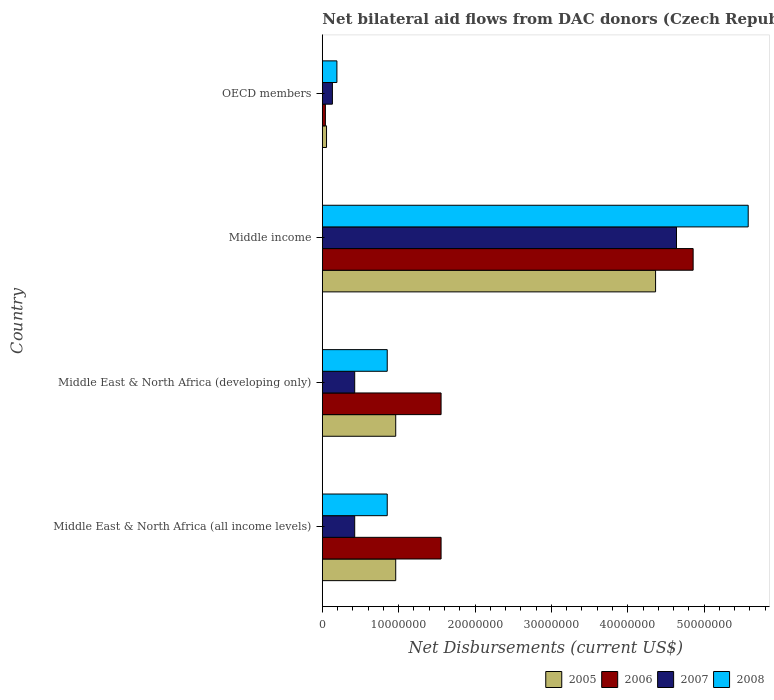How many different coloured bars are there?
Provide a succinct answer. 4. How many groups of bars are there?
Your answer should be compact. 4. How many bars are there on the 2nd tick from the top?
Your response must be concise. 4. What is the label of the 3rd group of bars from the top?
Give a very brief answer. Middle East & North Africa (developing only). In how many cases, is the number of bars for a given country not equal to the number of legend labels?
Your answer should be compact. 0. What is the net bilateral aid flows in 2008 in Middle income?
Ensure brevity in your answer.  5.58e+07. Across all countries, what is the maximum net bilateral aid flows in 2007?
Keep it short and to the point. 4.64e+07. Across all countries, what is the minimum net bilateral aid flows in 2005?
Ensure brevity in your answer.  5.50e+05. What is the total net bilateral aid flows in 2005 in the graph?
Make the answer very short. 6.34e+07. What is the difference between the net bilateral aid flows in 2008 in Middle East & North Africa (developing only) and that in OECD members?
Offer a very short reply. 6.59e+06. What is the difference between the net bilateral aid flows in 2005 in OECD members and the net bilateral aid flows in 2006 in Middle East & North Africa (all income levels)?
Your answer should be compact. -1.50e+07. What is the average net bilateral aid flows in 2006 per country?
Your answer should be very brief. 2.00e+07. What is the difference between the net bilateral aid flows in 2006 and net bilateral aid flows in 2005 in Middle East & North Africa (developing only)?
Provide a short and direct response. 5.94e+06. What is the ratio of the net bilateral aid flows in 2005 in Middle East & North Africa (all income levels) to that in OECD members?
Make the answer very short. 17.47. What is the difference between the highest and the second highest net bilateral aid flows in 2007?
Your response must be concise. 4.21e+07. What is the difference between the highest and the lowest net bilateral aid flows in 2008?
Your answer should be compact. 5.39e+07. In how many countries, is the net bilateral aid flows in 2005 greater than the average net bilateral aid flows in 2005 taken over all countries?
Provide a succinct answer. 1. Is the sum of the net bilateral aid flows in 2007 in Middle East & North Africa (all income levels) and Middle East & North Africa (developing only) greater than the maximum net bilateral aid flows in 2005 across all countries?
Keep it short and to the point. No. Is it the case that in every country, the sum of the net bilateral aid flows in 2008 and net bilateral aid flows in 2007 is greater than the sum of net bilateral aid flows in 2006 and net bilateral aid flows in 2005?
Give a very brief answer. No. How many bars are there?
Your response must be concise. 16. Are all the bars in the graph horizontal?
Offer a very short reply. Yes. How many countries are there in the graph?
Provide a succinct answer. 4. Are the values on the major ticks of X-axis written in scientific E-notation?
Make the answer very short. No. Does the graph contain any zero values?
Provide a succinct answer. No. Where does the legend appear in the graph?
Offer a very short reply. Bottom right. What is the title of the graph?
Provide a short and direct response. Net bilateral aid flows from DAC donors (Czech Republic). Does "1996" appear as one of the legend labels in the graph?
Ensure brevity in your answer.  No. What is the label or title of the X-axis?
Your answer should be compact. Net Disbursements (current US$). What is the label or title of the Y-axis?
Make the answer very short. Country. What is the Net Disbursements (current US$) in 2005 in Middle East & North Africa (all income levels)?
Your answer should be very brief. 9.61e+06. What is the Net Disbursements (current US$) of 2006 in Middle East & North Africa (all income levels)?
Keep it short and to the point. 1.56e+07. What is the Net Disbursements (current US$) of 2007 in Middle East & North Africa (all income levels)?
Ensure brevity in your answer.  4.24e+06. What is the Net Disbursements (current US$) in 2008 in Middle East & North Africa (all income levels)?
Your answer should be very brief. 8.50e+06. What is the Net Disbursements (current US$) of 2005 in Middle East & North Africa (developing only)?
Provide a succinct answer. 9.61e+06. What is the Net Disbursements (current US$) in 2006 in Middle East & North Africa (developing only)?
Your response must be concise. 1.56e+07. What is the Net Disbursements (current US$) in 2007 in Middle East & North Africa (developing only)?
Ensure brevity in your answer.  4.24e+06. What is the Net Disbursements (current US$) of 2008 in Middle East & North Africa (developing only)?
Your response must be concise. 8.50e+06. What is the Net Disbursements (current US$) of 2005 in Middle income?
Give a very brief answer. 4.36e+07. What is the Net Disbursements (current US$) in 2006 in Middle income?
Your answer should be compact. 4.86e+07. What is the Net Disbursements (current US$) in 2007 in Middle income?
Give a very brief answer. 4.64e+07. What is the Net Disbursements (current US$) of 2008 in Middle income?
Your response must be concise. 5.58e+07. What is the Net Disbursements (current US$) of 2007 in OECD members?
Provide a succinct answer. 1.32e+06. What is the Net Disbursements (current US$) in 2008 in OECD members?
Ensure brevity in your answer.  1.91e+06. Across all countries, what is the maximum Net Disbursements (current US$) in 2005?
Offer a terse response. 4.36e+07. Across all countries, what is the maximum Net Disbursements (current US$) of 2006?
Your answer should be compact. 4.86e+07. Across all countries, what is the maximum Net Disbursements (current US$) of 2007?
Offer a very short reply. 4.64e+07. Across all countries, what is the maximum Net Disbursements (current US$) in 2008?
Give a very brief answer. 5.58e+07. Across all countries, what is the minimum Net Disbursements (current US$) of 2005?
Offer a very short reply. 5.50e+05. Across all countries, what is the minimum Net Disbursements (current US$) in 2006?
Ensure brevity in your answer.  4.00e+05. Across all countries, what is the minimum Net Disbursements (current US$) in 2007?
Your answer should be very brief. 1.32e+06. Across all countries, what is the minimum Net Disbursements (current US$) in 2008?
Provide a succinct answer. 1.91e+06. What is the total Net Disbursements (current US$) in 2005 in the graph?
Provide a short and direct response. 6.34e+07. What is the total Net Disbursements (current US$) of 2006 in the graph?
Your answer should be compact. 8.01e+07. What is the total Net Disbursements (current US$) of 2007 in the graph?
Your answer should be very brief. 5.62e+07. What is the total Net Disbursements (current US$) in 2008 in the graph?
Ensure brevity in your answer.  7.47e+07. What is the difference between the Net Disbursements (current US$) of 2005 in Middle East & North Africa (all income levels) and that in Middle East & North Africa (developing only)?
Offer a very short reply. 0. What is the difference between the Net Disbursements (current US$) in 2006 in Middle East & North Africa (all income levels) and that in Middle East & North Africa (developing only)?
Offer a very short reply. 0. What is the difference between the Net Disbursements (current US$) in 2007 in Middle East & North Africa (all income levels) and that in Middle East & North Africa (developing only)?
Offer a terse response. 0. What is the difference between the Net Disbursements (current US$) of 2005 in Middle East & North Africa (all income levels) and that in Middle income?
Provide a short and direct response. -3.40e+07. What is the difference between the Net Disbursements (current US$) in 2006 in Middle East & North Africa (all income levels) and that in Middle income?
Ensure brevity in your answer.  -3.30e+07. What is the difference between the Net Disbursements (current US$) of 2007 in Middle East & North Africa (all income levels) and that in Middle income?
Offer a terse response. -4.21e+07. What is the difference between the Net Disbursements (current US$) of 2008 in Middle East & North Africa (all income levels) and that in Middle income?
Offer a terse response. -4.73e+07. What is the difference between the Net Disbursements (current US$) in 2005 in Middle East & North Africa (all income levels) and that in OECD members?
Your response must be concise. 9.06e+06. What is the difference between the Net Disbursements (current US$) in 2006 in Middle East & North Africa (all income levels) and that in OECD members?
Offer a very short reply. 1.52e+07. What is the difference between the Net Disbursements (current US$) in 2007 in Middle East & North Africa (all income levels) and that in OECD members?
Offer a very short reply. 2.92e+06. What is the difference between the Net Disbursements (current US$) in 2008 in Middle East & North Africa (all income levels) and that in OECD members?
Provide a short and direct response. 6.59e+06. What is the difference between the Net Disbursements (current US$) of 2005 in Middle East & North Africa (developing only) and that in Middle income?
Offer a very short reply. -3.40e+07. What is the difference between the Net Disbursements (current US$) of 2006 in Middle East & North Africa (developing only) and that in Middle income?
Provide a succinct answer. -3.30e+07. What is the difference between the Net Disbursements (current US$) of 2007 in Middle East & North Africa (developing only) and that in Middle income?
Offer a terse response. -4.21e+07. What is the difference between the Net Disbursements (current US$) of 2008 in Middle East & North Africa (developing only) and that in Middle income?
Offer a terse response. -4.73e+07. What is the difference between the Net Disbursements (current US$) of 2005 in Middle East & North Africa (developing only) and that in OECD members?
Ensure brevity in your answer.  9.06e+06. What is the difference between the Net Disbursements (current US$) of 2006 in Middle East & North Africa (developing only) and that in OECD members?
Give a very brief answer. 1.52e+07. What is the difference between the Net Disbursements (current US$) of 2007 in Middle East & North Africa (developing only) and that in OECD members?
Your answer should be very brief. 2.92e+06. What is the difference between the Net Disbursements (current US$) in 2008 in Middle East & North Africa (developing only) and that in OECD members?
Give a very brief answer. 6.59e+06. What is the difference between the Net Disbursements (current US$) of 2005 in Middle income and that in OECD members?
Provide a succinct answer. 4.31e+07. What is the difference between the Net Disbursements (current US$) of 2006 in Middle income and that in OECD members?
Your answer should be compact. 4.82e+07. What is the difference between the Net Disbursements (current US$) of 2007 in Middle income and that in OECD members?
Offer a very short reply. 4.51e+07. What is the difference between the Net Disbursements (current US$) in 2008 in Middle income and that in OECD members?
Your answer should be very brief. 5.39e+07. What is the difference between the Net Disbursements (current US$) in 2005 in Middle East & North Africa (all income levels) and the Net Disbursements (current US$) in 2006 in Middle East & North Africa (developing only)?
Provide a succinct answer. -5.94e+06. What is the difference between the Net Disbursements (current US$) of 2005 in Middle East & North Africa (all income levels) and the Net Disbursements (current US$) of 2007 in Middle East & North Africa (developing only)?
Give a very brief answer. 5.37e+06. What is the difference between the Net Disbursements (current US$) of 2005 in Middle East & North Africa (all income levels) and the Net Disbursements (current US$) of 2008 in Middle East & North Africa (developing only)?
Provide a short and direct response. 1.11e+06. What is the difference between the Net Disbursements (current US$) of 2006 in Middle East & North Africa (all income levels) and the Net Disbursements (current US$) of 2007 in Middle East & North Africa (developing only)?
Make the answer very short. 1.13e+07. What is the difference between the Net Disbursements (current US$) in 2006 in Middle East & North Africa (all income levels) and the Net Disbursements (current US$) in 2008 in Middle East & North Africa (developing only)?
Give a very brief answer. 7.05e+06. What is the difference between the Net Disbursements (current US$) in 2007 in Middle East & North Africa (all income levels) and the Net Disbursements (current US$) in 2008 in Middle East & North Africa (developing only)?
Make the answer very short. -4.26e+06. What is the difference between the Net Disbursements (current US$) of 2005 in Middle East & North Africa (all income levels) and the Net Disbursements (current US$) of 2006 in Middle income?
Keep it short and to the point. -3.90e+07. What is the difference between the Net Disbursements (current US$) of 2005 in Middle East & North Africa (all income levels) and the Net Disbursements (current US$) of 2007 in Middle income?
Provide a succinct answer. -3.68e+07. What is the difference between the Net Disbursements (current US$) of 2005 in Middle East & North Africa (all income levels) and the Net Disbursements (current US$) of 2008 in Middle income?
Provide a succinct answer. -4.62e+07. What is the difference between the Net Disbursements (current US$) in 2006 in Middle East & North Africa (all income levels) and the Net Disbursements (current US$) in 2007 in Middle income?
Ensure brevity in your answer.  -3.08e+07. What is the difference between the Net Disbursements (current US$) of 2006 in Middle East & North Africa (all income levels) and the Net Disbursements (current US$) of 2008 in Middle income?
Give a very brief answer. -4.02e+07. What is the difference between the Net Disbursements (current US$) in 2007 in Middle East & North Africa (all income levels) and the Net Disbursements (current US$) in 2008 in Middle income?
Ensure brevity in your answer.  -5.15e+07. What is the difference between the Net Disbursements (current US$) of 2005 in Middle East & North Africa (all income levels) and the Net Disbursements (current US$) of 2006 in OECD members?
Ensure brevity in your answer.  9.21e+06. What is the difference between the Net Disbursements (current US$) of 2005 in Middle East & North Africa (all income levels) and the Net Disbursements (current US$) of 2007 in OECD members?
Your response must be concise. 8.29e+06. What is the difference between the Net Disbursements (current US$) in 2005 in Middle East & North Africa (all income levels) and the Net Disbursements (current US$) in 2008 in OECD members?
Give a very brief answer. 7.70e+06. What is the difference between the Net Disbursements (current US$) in 2006 in Middle East & North Africa (all income levels) and the Net Disbursements (current US$) in 2007 in OECD members?
Ensure brevity in your answer.  1.42e+07. What is the difference between the Net Disbursements (current US$) in 2006 in Middle East & North Africa (all income levels) and the Net Disbursements (current US$) in 2008 in OECD members?
Your answer should be compact. 1.36e+07. What is the difference between the Net Disbursements (current US$) in 2007 in Middle East & North Africa (all income levels) and the Net Disbursements (current US$) in 2008 in OECD members?
Offer a very short reply. 2.33e+06. What is the difference between the Net Disbursements (current US$) in 2005 in Middle East & North Africa (developing only) and the Net Disbursements (current US$) in 2006 in Middle income?
Your answer should be compact. -3.90e+07. What is the difference between the Net Disbursements (current US$) of 2005 in Middle East & North Africa (developing only) and the Net Disbursements (current US$) of 2007 in Middle income?
Offer a terse response. -3.68e+07. What is the difference between the Net Disbursements (current US$) in 2005 in Middle East & North Africa (developing only) and the Net Disbursements (current US$) in 2008 in Middle income?
Provide a succinct answer. -4.62e+07. What is the difference between the Net Disbursements (current US$) of 2006 in Middle East & North Africa (developing only) and the Net Disbursements (current US$) of 2007 in Middle income?
Give a very brief answer. -3.08e+07. What is the difference between the Net Disbursements (current US$) in 2006 in Middle East & North Africa (developing only) and the Net Disbursements (current US$) in 2008 in Middle income?
Offer a very short reply. -4.02e+07. What is the difference between the Net Disbursements (current US$) of 2007 in Middle East & North Africa (developing only) and the Net Disbursements (current US$) of 2008 in Middle income?
Your answer should be very brief. -5.15e+07. What is the difference between the Net Disbursements (current US$) in 2005 in Middle East & North Africa (developing only) and the Net Disbursements (current US$) in 2006 in OECD members?
Make the answer very short. 9.21e+06. What is the difference between the Net Disbursements (current US$) of 2005 in Middle East & North Africa (developing only) and the Net Disbursements (current US$) of 2007 in OECD members?
Offer a very short reply. 8.29e+06. What is the difference between the Net Disbursements (current US$) in 2005 in Middle East & North Africa (developing only) and the Net Disbursements (current US$) in 2008 in OECD members?
Offer a very short reply. 7.70e+06. What is the difference between the Net Disbursements (current US$) in 2006 in Middle East & North Africa (developing only) and the Net Disbursements (current US$) in 2007 in OECD members?
Offer a terse response. 1.42e+07. What is the difference between the Net Disbursements (current US$) in 2006 in Middle East & North Africa (developing only) and the Net Disbursements (current US$) in 2008 in OECD members?
Give a very brief answer. 1.36e+07. What is the difference between the Net Disbursements (current US$) of 2007 in Middle East & North Africa (developing only) and the Net Disbursements (current US$) of 2008 in OECD members?
Your answer should be compact. 2.33e+06. What is the difference between the Net Disbursements (current US$) of 2005 in Middle income and the Net Disbursements (current US$) of 2006 in OECD members?
Provide a succinct answer. 4.32e+07. What is the difference between the Net Disbursements (current US$) in 2005 in Middle income and the Net Disbursements (current US$) in 2007 in OECD members?
Your answer should be very brief. 4.23e+07. What is the difference between the Net Disbursements (current US$) of 2005 in Middle income and the Net Disbursements (current US$) of 2008 in OECD members?
Keep it short and to the point. 4.17e+07. What is the difference between the Net Disbursements (current US$) of 2006 in Middle income and the Net Disbursements (current US$) of 2007 in OECD members?
Offer a very short reply. 4.72e+07. What is the difference between the Net Disbursements (current US$) in 2006 in Middle income and the Net Disbursements (current US$) in 2008 in OECD members?
Give a very brief answer. 4.66e+07. What is the difference between the Net Disbursements (current US$) in 2007 in Middle income and the Net Disbursements (current US$) in 2008 in OECD members?
Keep it short and to the point. 4.45e+07. What is the average Net Disbursements (current US$) of 2005 per country?
Give a very brief answer. 1.59e+07. What is the average Net Disbursements (current US$) in 2006 per country?
Offer a very short reply. 2.00e+07. What is the average Net Disbursements (current US$) in 2007 per country?
Provide a short and direct response. 1.40e+07. What is the average Net Disbursements (current US$) of 2008 per country?
Your response must be concise. 1.87e+07. What is the difference between the Net Disbursements (current US$) of 2005 and Net Disbursements (current US$) of 2006 in Middle East & North Africa (all income levels)?
Keep it short and to the point. -5.94e+06. What is the difference between the Net Disbursements (current US$) in 2005 and Net Disbursements (current US$) in 2007 in Middle East & North Africa (all income levels)?
Ensure brevity in your answer.  5.37e+06. What is the difference between the Net Disbursements (current US$) in 2005 and Net Disbursements (current US$) in 2008 in Middle East & North Africa (all income levels)?
Provide a succinct answer. 1.11e+06. What is the difference between the Net Disbursements (current US$) of 2006 and Net Disbursements (current US$) of 2007 in Middle East & North Africa (all income levels)?
Provide a short and direct response. 1.13e+07. What is the difference between the Net Disbursements (current US$) of 2006 and Net Disbursements (current US$) of 2008 in Middle East & North Africa (all income levels)?
Your response must be concise. 7.05e+06. What is the difference between the Net Disbursements (current US$) of 2007 and Net Disbursements (current US$) of 2008 in Middle East & North Africa (all income levels)?
Offer a terse response. -4.26e+06. What is the difference between the Net Disbursements (current US$) of 2005 and Net Disbursements (current US$) of 2006 in Middle East & North Africa (developing only)?
Keep it short and to the point. -5.94e+06. What is the difference between the Net Disbursements (current US$) in 2005 and Net Disbursements (current US$) in 2007 in Middle East & North Africa (developing only)?
Make the answer very short. 5.37e+06. What is the difference between the Net Disbursements (current US$) of 2005 and Net Disbursements (current US$) of 2008 in Middle East & North Africa (developing only)?
Offer a very short reply. 1.11e+06. What is the difference between the Net Disbursements (current US$) in 2006 and Net Disbursements (current US$) in 2007 in Middle East & North Africa (developing only)?
Offer a terse response. 1.13e+07. What is the difference between the Net Disbursements (current US$) of 2006 and Net Disbursements (current US$) of 2008 in Middle East & North Africa (developing only)?
Give a very brief answer. 7.05e+06. What is the difference between the Net Disbursements (current US$) in 2007 and Net Disbursements (current US$) in 2008 in Middle East & North Africa (developing only)?
Your response must be concise. -4.26e+06. What is the difference between the Net Disbursements (current US$) of 2005 and Net Disbursements (current US$) of 2006 in Middle income?
Your answer should be compact. -4.92e+06. What is the difference between the Net Disbursements (current US$) of 2005 and Net Disbursements (current US$) of 2007 in Middle income?
Keep it short and to the point. -2.74e+06. What is the difference between the Net Disbursements (current US$) in 2005 and Net Disbursements (current US$) in 2008 in Middle income?
Your response must be concise. -1.21e+07. What is the difference between the Net Disbursements (current US$) in 2006 and Net Disbursements (current US$) in 2007 in Middle income?
Offer a very short reply. 2.18e+06. What is the difference between the Net Disbursements (current US$) in 2006 and Net Disbursements (current US$) in 2008 in Middle income?
Provide a succinct answer. -7.21e+06. What is the difference between the Net Disbursements (current US$) of 2007 and Net Disbursements (current US$) of 2008 in Middle income?
Provide a succinct answer. -9.39e+06. What is the difference between the Net Disbursements (current US$) of 2005 and Net Disbursements (current US$) of 2006 in OECD members?
Your answer should be very brief. 1.50e+05. What is the difference between the Net Disbursements (current US$) in 2005 and Net Disbursements (current US$) in 2007 in OECD members?
Give a very brief answer. -7.70e+05. What is the difference between the Net Disbursements (current US$) in 2005 and Net Disbursements (current US$) in 2008 in OECD members?
Offer a terse response. -1.36e+06. What is the difference between the Net Disbursements (current US$) of 2006 and Net Disbursements (current US$) of 2007 in OECD members?
Offer a very short reply. -9.20e+05. What is the difference between the Net Disbursements (current US$) of 2006 and Net Disbursements (current US$) of 2008 in OECD members?
Your answer should be compact. -1.51e+06. What is the difference between the Net Disbursements (current US$) in 2007 and Net Disbursements (current US$) in 2008 in OECD members?
Provide a succinct answer. -5.90e+05. What is the ratio of the Net Disbursements (current US$) of 2007 in Middle East & North Africa (all income levels) to that in Middle East & North Africa (developing only)?
Your response must be concise. 1. What is the ratio of the Net Disbursements (current US$) in 2005 in Middle East & North Africa (all income levels) to that in Middle income?
Give a very brief answer. 0.22. What is the ratio of the Net Disbursements (current US$) in 2006 in Middle East & North Africa (all income levels) to that in Middle income?
Your answer should be very brief. 0.32. What is the ratio of the Net Disbursements (current US$) of 2007 in Middle East & North Africa (all income levels) to that in Middle income?
Provide a succinct answer. 0.09. What is the ratio of the Net Disbursements (current US$) in 2008 in Middle East & North Africa (all income levels) to that in Middle income?
Give a very brief answer. 0.15. What is the ratio of the Net Disbursements (current US$) in 2005 in Middle East & North Africa (all income levels) to that in OECD members?
Your response must be concise. 17.47. What is the ratio of the Net Disbursements (current US$) of 2006 in Middle East & North Africa (all income levels) to that in OECD members?
Your answer should be compact. 38.88. What is the ratio of the Net Disbursements (current US$) in 2007 in Middle East & North Africa (all income levels) to that in OECD members?
Offer a very short reply. 3.21. What is the ratio of the Net Disbursements (current US$) in 2008 in Middle East & North Africa (all income levels) to that in OECD members?
Your answer should be compact. 4.45. What is the ratio of the Net Disbursements (current US$) in 2005 in Middle East & North Africa (developing only) to that in Middle income?
Your answer should be very brief. 0.22. What is the ratio of the Net Disbursements (current US$) of 2006 in Middle East & North Africa (developing only) to that in Middle income?
Keep it short and to the point. 0.32. What is the ratio of the Net Disbursements (current US$) of 2007 in Middle East & North Africa (developing only) to that in Middle income?
Your answer should be compact. 0.09. What is the ratio of the Net Disbursements (current US$) of 2008 in Middle East & North Africa (developing only) to that in Middle income?
Keep it short and to the point. 0.15. What is the ratio of the Net Disbursements (current US$) of 2005 in Middle East & North Africa (developing only) to that in OECD members?
Your response must be concise. 17.47. What is the ratio of the Net Disbursements (current US$) of 2006 in Middle East & North Africa (developing only) to that in OECD members?
Your response must be concise. 38.88. What is the ratio of the Net Disbursements (current US$) in 2007 in Middle East & North Africa (developing only) to that in OECD members?
Give a very brief answer. 3.21. What is the ratio of the Net Disbursements (current US$) of 2008 in Middle East & North Africa (developing only) to that in OECD members?
Your response must be concise. 4.45. What is the ratio of the Net Disbursements (current US$) of 2005 in Middle income to that in OECD members?
Your response must be concise. 79.35. What is the ratio of the Net Disbursements (current US$) of 2006 in Middle income to that in OECD members?
Provide a short and direct response. 121.4. What is the ratio of the Net Disbursements (current US$) in 2007 in Middle income to that in OECD members?
Your answer should be compact. 35.14. What is the ratio of the Net Disbursements (current US$) of 2008 in Middle income to that in OECD members?
Offer a terse response. 29.2. What is the difference between the highest and the second highest Net Disbursements (current US$) of 2005?
Make the answer very short. 3.40e+07. What is the difference between the highest and the second highest Net Disbursements (current US$) in 2006?
Ensure brevity in your answer.  3.30e+07. What is the difference between the highest and the second highest Net Disbursements (current US$) in 2007?
Your response must be concise. 4.21e+07. What is the difference between the highest and the second highest Net Disbursements (current US$) of 2008?
Make the answer very short. 4.73e+07. What is the difference between the highest and the lowest Net Disbursements (current US$) of 2005?
Make the answer very short. 4.31e+07. What is the difference between the highest and the lowest Net Disbursements (current US$) of 2006?
Keep it short and to the point. 4.82e+07. What is the difference between the highest and the lowest Net Disbursements (current US$) in 2007?
Keep it short and to the point. 4.51e+07. What is the difference between the highest and the lowest Net Disbursements (current US$) in 2008?
Provide a short and direct response. 5.39e+07. 